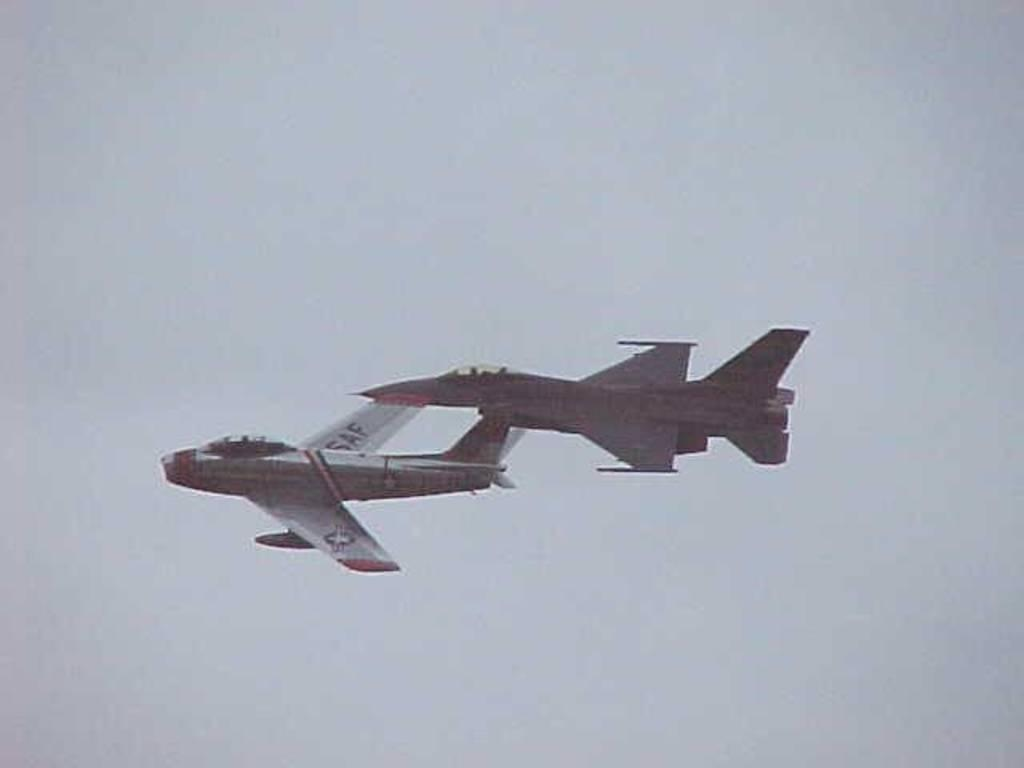What is the main subject of the image? The main subject of the image is two jet planes. Where are the jet planes located in the image? The jet planes are in the air and visible in the middle of the image. How many mice can be seen running on the wings of the jet planes in the image? There are no mice present in the image, and therefore no mice can be seen running on the wings of the jet planes. 